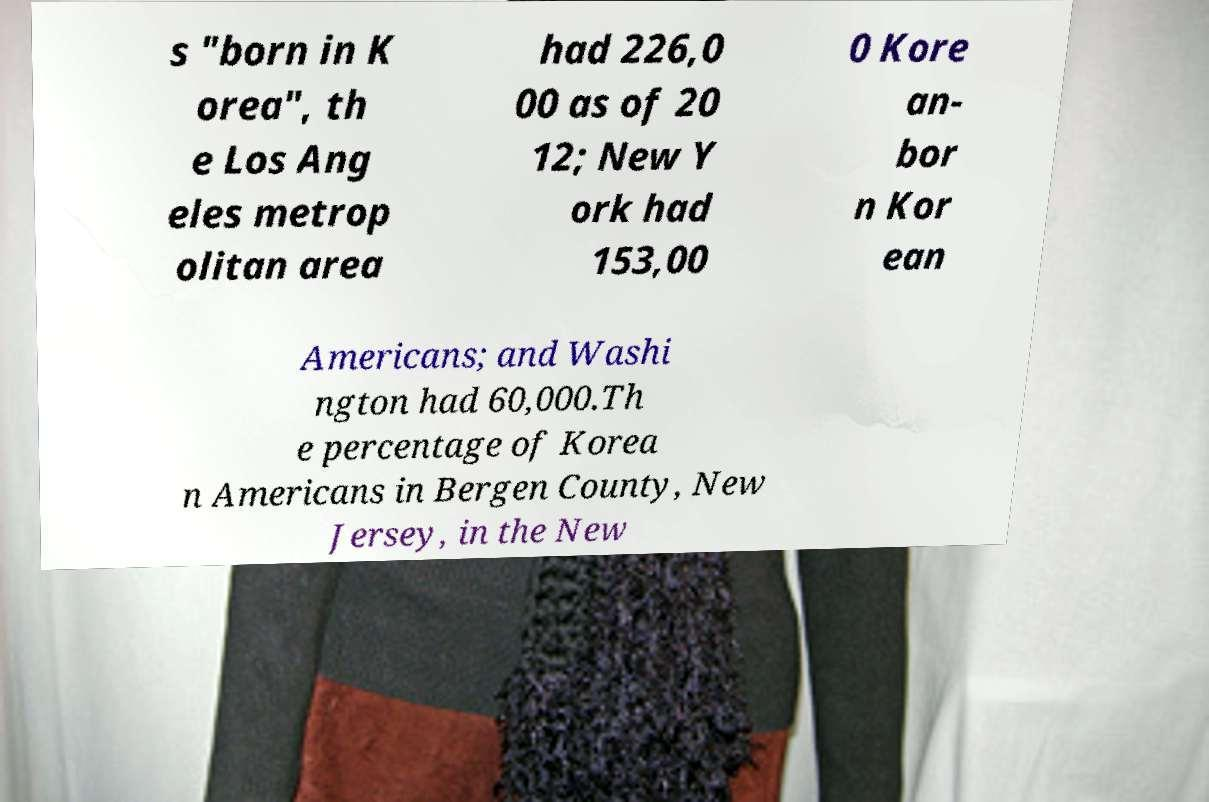Please identify and transcribe the text found in this image. s "born in K orea", th e Los Ang eles metrop olitan area had 226,0 00 as of 20 12; New Y ork had 153,00 0 Kore an- bor n Kor ean Americans; and Washi ngton had 60,000.Th e percentage of Korea n Americans in Bergen County, New Jersey, in the New 